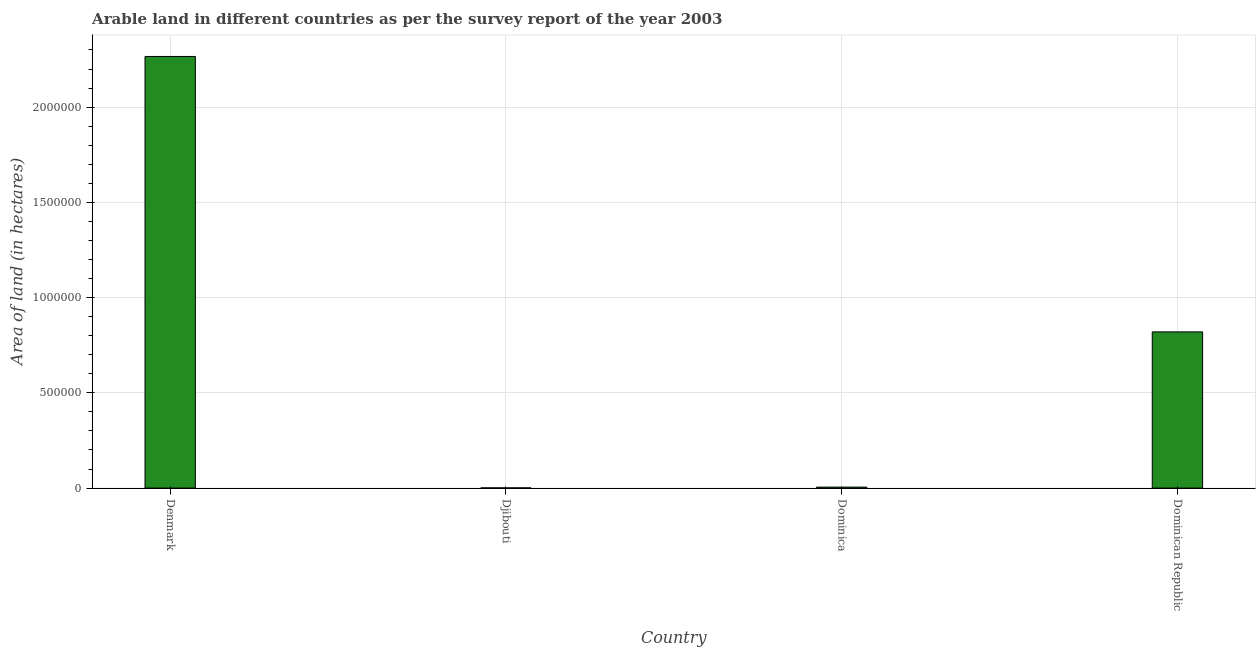Does the graph contain any zero values?
Offer a very short reply. No. What is the title of the graph?
Keep it short and to the point. Arable land in different countries as per the survey report of the year 2003. What is the label or title of the Y-axis?
Your answer should be compact. Area of land (in hectares). What is the area of land in Dominica?
Make the answer very short. 5000. Across all countries, what is the maximum area of land?
Your answer should be compact. 2.27e+06. Across all countries, what is the minimum area of land?
Offer a very short reply. 1000. In which country was the area of land minimum?
Make the answer very short. Djibouti. What is the sum of the area of land?
Provide a short and direct response. 3.09e+06. What is the difference between the area of land in Denmark and Djibouti?
Your response must be concise. 2.26e+06. What is the average area of land per country?
Offer a terse response. 7.73e+05. What is the median area of land?
Your answer should be very brief. 4.12e+05. In how many countries, is the area of land greater than 100000 hectares?
Your response must be concise. 2. What is the ratio of the area of land in Djibouti to that in Dominica?
Your answer should be very brief. 0.2. Is the area of land in Djibouti less than that in Dominica?
Your response must be concise. Yes. What is the difference between the highest and the second highest area of land?
Give a very brief answer. 1.45e+06. What is the difference between the highest and the lowest area of land?
Give a very brief answer. 2.26e+06. How many bars are there?
Ensure brevity in your answer.  4. Are all the bars in the graph horizontal?
Keep it short and to the point. No. Are the values on the major ticks of Y-axis written in scientific E-notation?
Offer a terse response. No. What is the Area of land (in hectares) of Denmark?
Offer a terse response. 2.27e+06. What is the Area of land (in hectares) of Dominica?
Your response must be concise. 5000. What is the Area of land (in hectares) in Dominican Republic?
Ensure brevity in your answer.  8.20e+05. What is the difference between the Area of land (in hectares) in Denmark and Djibouti?
Give a very brief answer. 2.26e+06. What is the difference between the Area of land (in hectares) in Denmark and Dominica?
Ensure brevity in your answer.  2.26e+06. What is the difference between the Area of land (in hectares) in Denmark and Dominican Republic?
Provide a short and direct response. 1.45e+06. What is the difference between the Area of land (in hectares) in Djibouti and Dominica?
Keep it short and to the point. -4000. What is the difference between the Area of land (in hectares) in Djibouti and Dominican Republic?
Provide a succinct answer. -8.19e+05. What is the difference between the Area of land (in hectares) in Dominica and Dominican Republic?
Your response must be concise. -8.15e+05. What is the ratio of the Area of land (in hectares) in Denmark to that in Djibouti?
Provide a succinct answer. 2266. What is the ratio of the Area of land (in hectares) in Denmark to that in Dominica?
Ensure brevity in your answer.  453.2. What is the ratio of the Area of land (in hectares) in Denmark to that in Dominican Republic?
Keep it short and to the point. 2.76. What is the ratio of the Area of land (in hectares) in Dominica to that in Dominican Republic?
Provide a short and direct response. 0.01. 